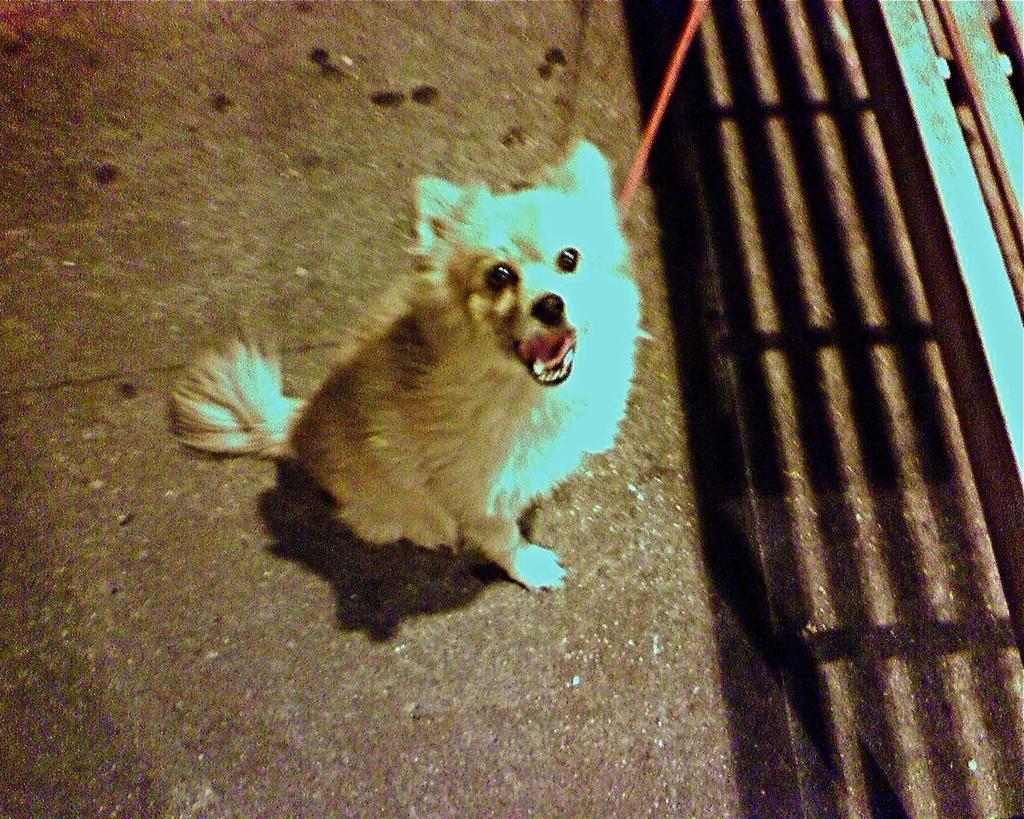Could you give a brief overview of what you see in this image? In this image there is a dog on a road, on the right side there is a bench. 